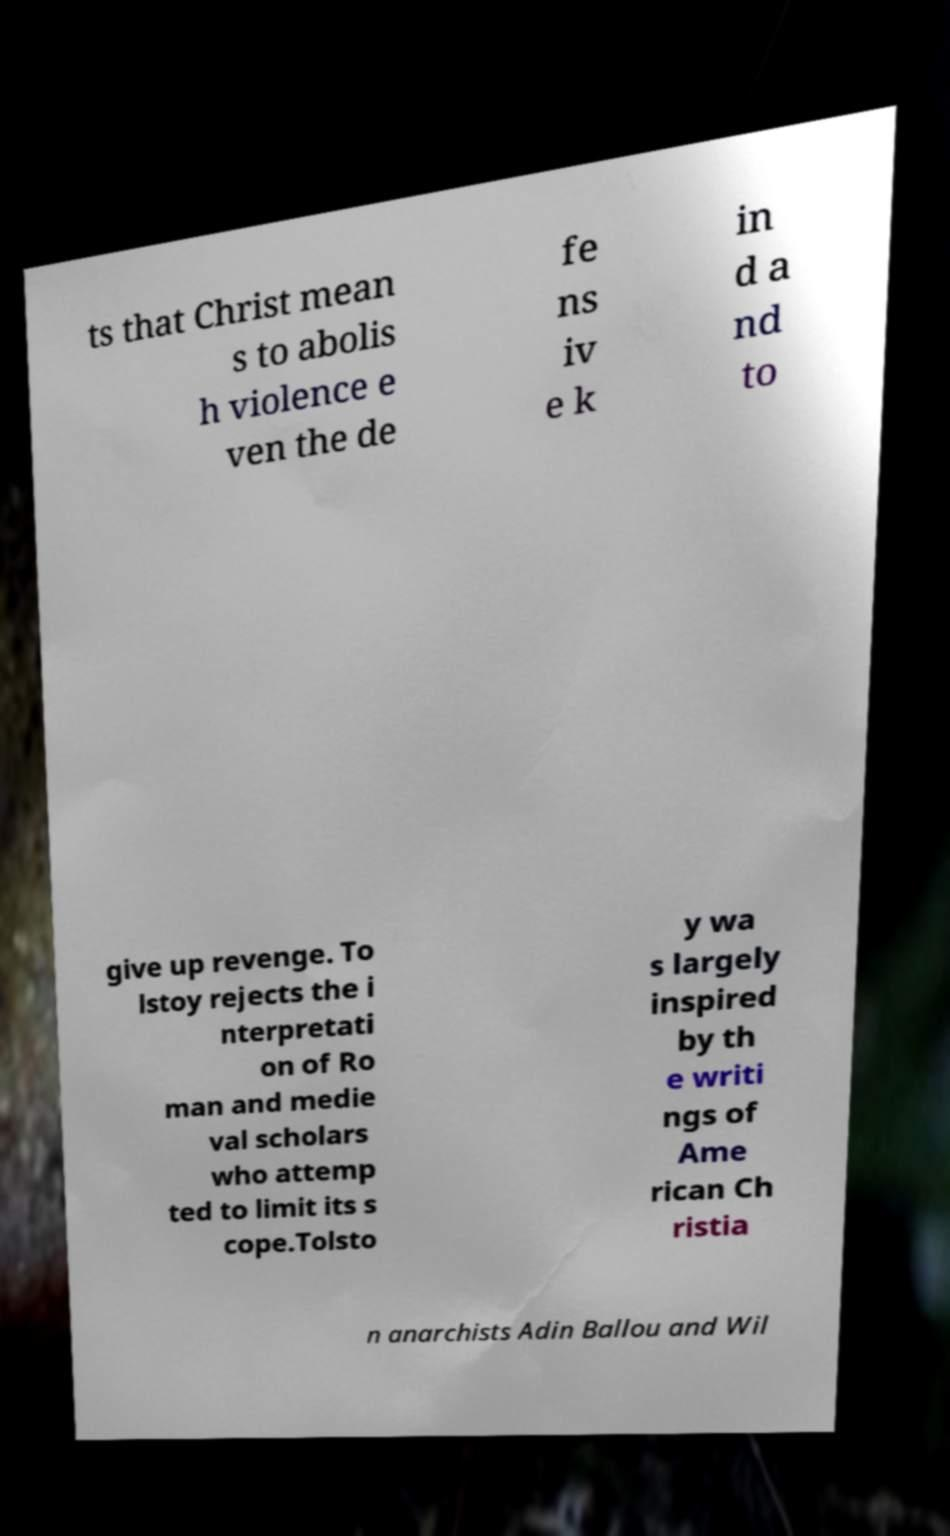There's text embedded in this image that I need extracted. Can you transcribe it verbatim? ts that Christ mean s to abolis h violence e ven the de fe ns iv e k in d a nd to give up revenge. To lstoy rejects the i nterpretati on of Ro man and medie val scholars who attemp ted to limit its s cope.Tolsto y wa s largely inspired by th e writi ngs of Ame rican Ch ristia n anarchists Adin Ballou and Wil 